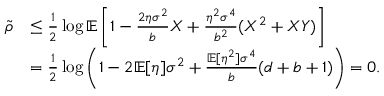Convert formula to latex. <formula><loc_0><loc_0><loc_500><loc_500>\begin{array} { r l } { \tilde { \rho } } & { \leq \frac { 1 } { 2 } \log \mathbb { E } \left [ 1 - \frac { 2 \eta \sigma ^ { 2 } } { b } X + \frac { \eta ^ { 2 } \sigma ^ { 4 } } { b ^ { 2 } } ( X ^ { 2 } + X Y ) \right ] } \\ & { = \frac { 1 } { 2 } \log \left ( 1 - 2 \mathbb { E } [ \eta ] \sigma ^ { 2 } + \frac { \mathbb { E } [ \eta ^ { 2 } ] \sigma ^ { 4 } } { b } ( d + b + 1 ) \right ) = 0 . } \end{array}</formula> 